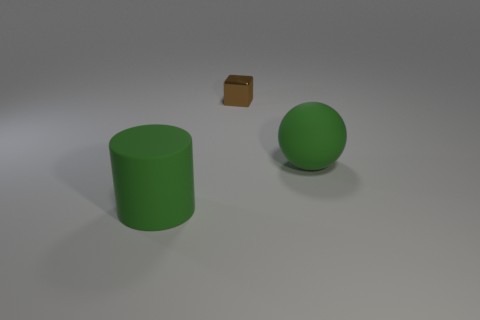Could you propose a hypothesis about the relationship between these objects? Considering the isolated setting and the arrangement of the objects, it might represent a basic study of shapes and textures in 3D modeling. The composition gives an impression of a simple spatial relationship, with no evident functional interaction between the items. 